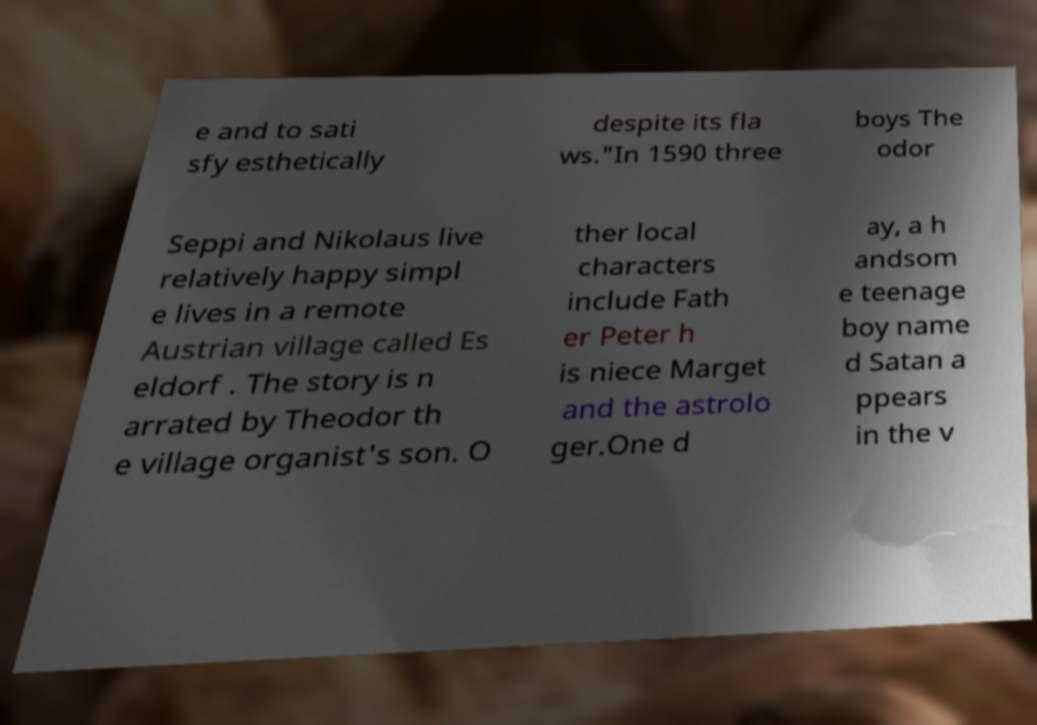Can you accurately transcribe the text from the provided image for me? e and to sati sfy esthetically despite its fla ws."In 1590 three boys The odor Seppi and Nikolaus live relatively happy simpl e lives in a remote Austrian village called Es eldorf . The story is n arrated by Theodor th e village organist's son. O ther local characters include Fath er Peter h is niece Marget and the astrolo ger.One d ay, a h andsom e teenage boy name d Satan a ppears in the v 